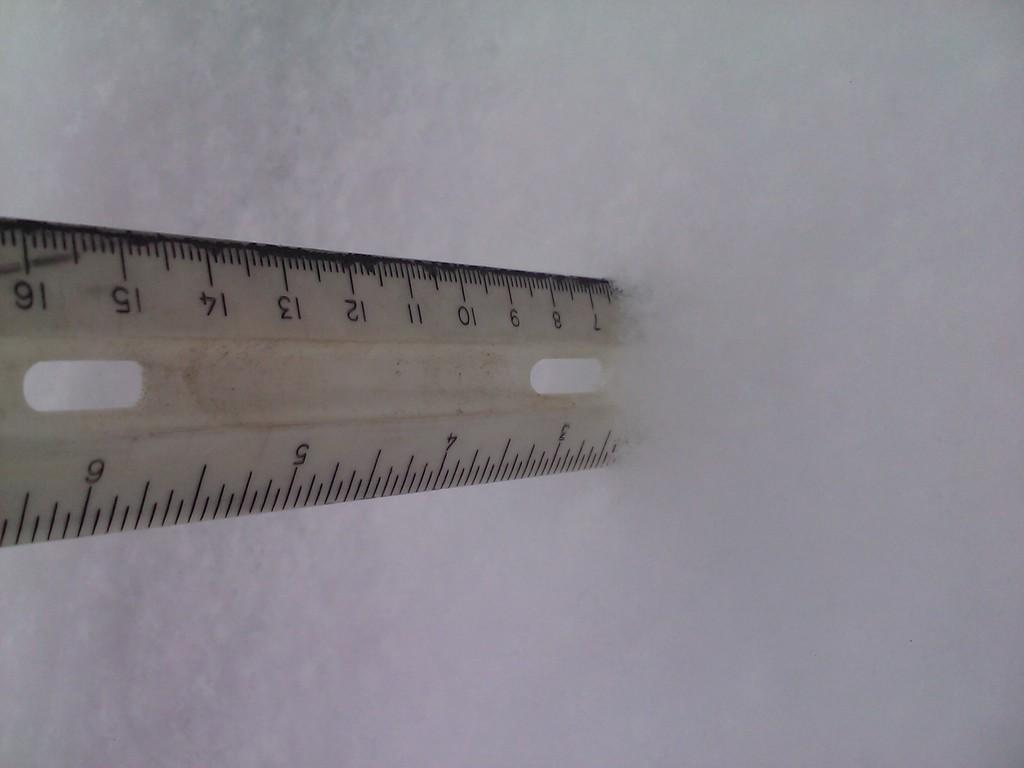<image>
Share a concise interpretation of the image provided. a ruler in in the snow near the 3 inch mark 